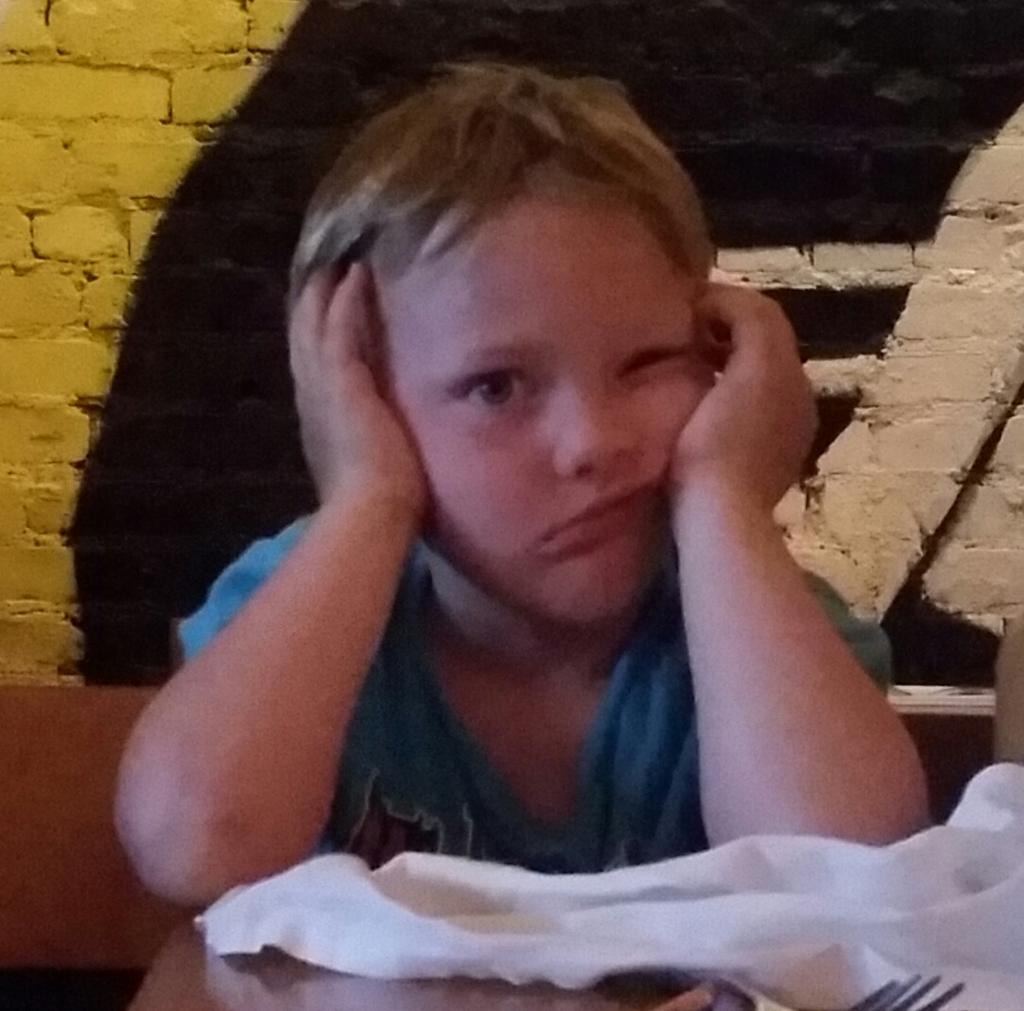What is the person in the image doing? There is a person sitting in the image. What is the person wearing? The person is wearing a blue dress. What can be seen on the table in the image? A white cloth and a fork are visible on the table. How would you describe the colors on the wall in the image? The wall has yellow, black, and cream colors. What is the temperature downtown according to the image? The image does not provide any information about the temperature downtown. 